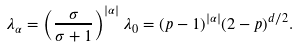<formula> <loc_0><loc_0><loc_500><loc_500>\lambda _ { \alpha } = \left ( \frac { \sigma } { \sigma + 1 } \right ) ^ { | \alpha | } \lambda _ { 0 } = ( p - 1 ) ^ { | \alpha | } ( 2 - p ) ^ { d / 2 } .</formula> 